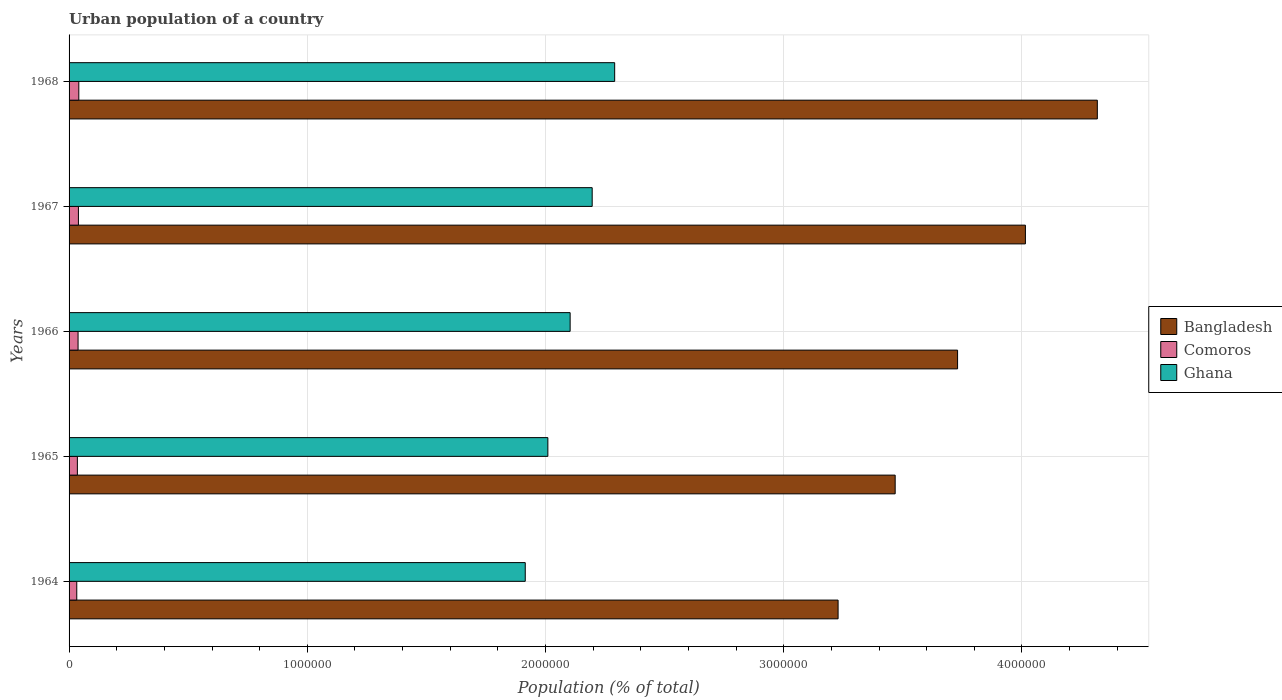How many bars are there on the 3rd tick from the top?
Your response must be concise. 3. What is the label of the 3rd group of bars from the top?
Ensure brevity in your answer.  1966. What is the urban population in Ghana in 1966?
Make the answer very short. 2.10e+06. Across all years, what is the maximum urban population in Ghana?
Provide a short and direct response. 2.29e+06. Across all years, what is the minimum urban population in Ghana?
Provide a succinct answer. 1.91e+06. In which year was the urban population in Comoros maximum?
Offer a very short reply. 1968. In which year was the urban population in Ghana minimum?
Offer a very short reply. 1964. What is the total urban population in Comoros in the graph?
Offer a terse response. 1.85e+05. What is the difference between the urban population in Comoros in 1965 and that in 1967?
Make the answer very short. -4380. What is the difference between the urban population in Ghana in 1966 and the urban population in Bangladesh in 1968?
Keep it short and to the point. -2.21e+06. What is the average urban population in Ghana per year?
Provide a succinct answer. 2.10e+06. In the year 1964, what is the difference between the urban population in Ghana and urban population in Comoros?
Offer a very short reply. 1.88e+06. What is the ratio of the urban population in Comoros in 1965 to that in 1968?
Keep it short and to the point. 0.85. Is the difference between the urban population in Ghana in 1966 and 1968 greater than the difference between the urban population in Comoros in 1966 and 1968?
Give a very brief answer. No. What is the difference between the highest and the second highest urban population in Bangladesh?
Make the answer very short. 3.02e+05. What is the difference between the highest and the lowest urban population in Ghana?
Your response must be concise. 3.75e+05. Is the sum of the urban population in Comoros in 1965 and 1966 greater than the maximum urban population in Bangladesh across all years?
Keep it short and to the point. No. What does the 2nd bar from the top in 1967 represents?
Your response must be concise. Comoros. What does the 2nd bar from the bottom in 1966 represents?
Offer a terse response. Comoros. How many bars are there?
Provide a short and direct response. 15. Are all the bars in the graph horizontal?
Make the answer very short. Yes. What is the difference between two consecutive major ticks on the X-axis?
Offer a terse response. 1.00e+06. Are the values on the major ticks of X-axis written in scientific E-notation?
Give a very brief answer. No. Does the graph contain grids?
Give a very brief answer. Yes. Where does the legend appear in the graph?
Your answer should be compact. Center right. How are the legend labels stacked?
Your answer should be very brief. Vertical. What is the title of the graph?
Ensure brevity in your answer.  Urban population of a country. Does "OECD members" appear as one of the legend labels in the graph?
Your answer should be very brief. No. What is the label or title of the X-axis?
Offer a very short reply. Population (% of total). What is the Population (% of total) in Bangladesh in 1964?
Offer a very short reply. 3.23e+06. What is the Population (% of total) of Comoros in 1964?
Make the answer very short. 3.23e+04. What is the Population (% of total) of Ghana in 1964?
Provide a succinct answer. 1.91e+06. What is the Population (% of total) in Bangladesh in 1965?
Provide a short and direct response. 3.47e+06. What is the Population (% of total) in Comoros in 1965?
Keep it short and to the point. 3.49e+04. What is the Population (% of total) in Ghana in 1965?
Your answer should be compact. 2.01e+06. What is the Population (% of total) in Bangladesh in 1966?
Your answer should be compact. 3.73e+06. What is the Population (% of total) of Comoros in 1966?
Keep it short and to the point. 3.77e+04. What is the Population (% of total) of Ghana in 1966?
Provide a short and direct response. 2.10e+06. What is the Population (% of total) of Bangladesh in 1967?
Your answer should be very brief. 4.01e+06. What is the Population (% of total) in Comoros in 1967?
Provide a succinct answer. 3.93e+04. What is the Population (% of total) in Ghana in 1967?
Your response must be concise. 2.20e+06. What is the Population (% of total) of Bangladesh in 1968?
Your answer should be very brief. 4.32e+06. What is the Population (% of total) in Comoros in 1968?
Keep it short and to the point. 4.09e+04. What is the Population (% of total) of Ghana in 1968?
Provide a succinct answer. 2.29e+06. Across all years, what is the maximum Population (% of total) of Bangladesh?
Offer a terse response. 4.32e+06. Across all years, what is the maximum Population (% of total) of Comoros?
Make the answer very short. 4.09e+04. Across all years, what is the maximum Population (% of total) of Ghana?
Your answer should be very brief. 2.29e+06. Across all years, what is the minimum Population (% of total) of Bangladesh?
Give a very brief answer. 3.23e+06. Across all years, what is the minimum Population (% of total) in Comoros?
Offer a very short reply. 3.23e+04. Across all years, what is the minimum Population (% of total) in Ghana?
Provide a succinct answer. 1.91e+06. What is the total Population (% of total) of Bangladesh in the graph?
Offer a very short reply. 1.88e+07. What is the total Population (% of total) in Comoros in the graph?
Offer a terse response. 1.85e+05. What is the total Population (% of total) of Ghana in the graph?
Your response must be concise. 1.05e+07. What is the difference between the Population (% of total) of Bangladesh in 1964 and that in 1965?
Your answer should be very brief. -2.40e+05. What is the difference between the Population (% of total) in Comoros in 1964 and that in 1965?
Your answer should be very brief. -2601. What is the difference between the Population (% of total) in Ghana in 1964 and that in 1965?
Offer a very short reply. -9.49e+04. What is the difference between the Population (% of total) of Bangladesh in 1964 and that in 1966?
Provide a succinct answer. -5.02e+05. What is the difference between the Population (% of total) in Comoros in 1964 and that in 1966?
Offer a terse response. -5442. What is the difference between the Population (% of total) in Ghana in 1964 and that in 1966?
Ensure brevity in your answer.  -1.88e+05. What is the difference between the Population (% of total) of Bangladesh in 1964 and that in 1967?
Provide a short and direct response. -7.86e+05. What is the difference between the Population (% of total) of Comoros in 1964 and that in 1967?
Your response must be concise. -6981. What is the difference between the Population (% of total) in Ghana in 1964 and that in 1967?
Your answer should be compact. -2.81e+05. What is the difference between the Population (% of total) in Bangladesh in 1964 and that in 1968?
Your response must be concise. -1.09e+06. What is the difference between the Population (% of total) in Comoros in 1964 and that in 1968?
Your response must be concise. -8608. What is the difference between the Population (% of total) of Ghana in 1964 and that in 1968?
Offer a terse response. -3.75e+05. What is the difference between the Population (% of total) in Bangladesh in 1965 and that in 1966?
Offer a terse response. -2.62e+05. What is the difference between the Population (% of total) in Comoros in 1965 and that in 1966?
Your response must be concise. -2841. What is the difference between the Population (% of total) of Ghana in 1965 and that in 1966?
Offer a terse response. -9.35e+04. What is the difference between the Population (% of total) of Bangladesh in 1965 and that in 1967?
Your response must be concise. -5.47e+05. What is the difference between the Population (% of total) in Comoros in 1965 and that in 1967?
Your answer should be very brief. -4380. What is the difference between the Population (% of total) in Ghana in 1965 and that in 1967?
Ensure brevity in your answer.  -1.86e+05. What is the difference between the Population (% of total) in Bangladesh in 1965 and that in 1968?
Your answer should be very brief. -8.49e+05. What is the difference between the Population (% of total) of Comoros in 1965 and that in 1968?
Your answer should be compact. -6007. What is the difference between the Population (% of total) in Ghana in 1965 and that in 1968?
Your answer should be very brief. -2.80e+05. What is the difference between the Population (% of total) in Bangladesh in 1966 and that in 1967?
Provide a succinct answer. -2.85e+05. What is the difference between the Population (% of total) in Comoros in 1966 and that in 1967?
Give a very brief answer. -1539. What is the difference between the Population (% of total) of Ghana in 1966 and that in 1967?
Give a very brief answer. -9.26e+04. What is the difference between the Population (% of total) of Bangladesh in 1966 and that in 1968?
Make the answer very short. -5.87e+05. What is the difference between the Population (% of total) of Comoros in 1966 and that in 1968?
Provide a short and direct response. -3166. What is the difference between the Population (% of total) of Ghana in 1966 and that in 1968?
Make the answer very short. -1.87e+05. What is the difference between the Population (% of total) of Bangladesh in 1967 and that in 1968?
Keep it short and to the point. -3.02e+05. What is the difference between the Population (% of total) in Comoros in 1967 and that in 1968?
Your answer should be compact. -1627. What is the difference between the Population (% of total) of Ghana in 1967 and that in 1968?
Keep it short and to the point. -9.44e+04. What is the difference between the Population (% of total) of Bangladesh in 1964 and the Population (% of total) of Comoros in 1965?
Offer a terse response. 3.19e+06. What is the difference between the Population (% of total) of Bangladesh in 1964 and the Population (% of total) of Ghana in 1965?
Ensure brevity in your answer.  1.22e+06. What is the difference between the Population (% of total) in Comoros in 1964 and the Population (% of total) in Ghana in 1965?
Your response must be concise. -1.98e+06. What is the difference between the Population (% of total) in Bangladesh in 1964 and the Population (% of total) in Comoros in 1966?
Provide a short and direct response. 3.19e+06. What is the difference between the Population (% of total) of Bangladesh in 1964 and the Population (% of total) of Ghana in 1966?
Your answer should be very brief. 1.12e+06. What is the difference between the Population (% of total) in Comoros in 1964 and the Population (% of total) in Ghana in 1966?
Ensure brevity in your answer.  -2.07e+06. What is the difference between the Population (% of total) in Bangladesh in 1964 and the Population (% of total) in Comoros in 1967?
Offer a terse response. 3.19e+06. What is the difference between the Population (% of total) in Bangladesh in 1964 and the Population (% of total) in Ghana in 1967?
Ensure brevity in your answer.  1.03e+06. What is the difference between the Population (% of total) in Comoros in 1964 and the Population (% of total) in Ghana in 1967?
Your answer should be very brief. -2.16e+06. What is the difference between the Population (% of total) in Bangladesh in 1964 and the Population (% of total) in Comoros in 1968?
Provide a short and direct response. 3.19e+06. What is the difference between the Population (% of total) in Bangladesh in 1964 and the Population (% of total) in Ghana in 1968?
Provide a succinct answer. 9.38e+05. What is the difference between the Population (% of total) in Comoros in 1964 and the Population (% of total) in Ghana in 1968?
Your answer should be very brief. -2.26e+06. What is the difference between the Population (% of total) of Bangladesh in 1965 and the Population (% of total) of Comoros in 1966?
Provide a short and direct response. 3.43e+06. What is the difference between the Population (% of total) of Bangladesh in 1965 and the Population (% of total) of Ghana in 1966?
Provide a short and direct response. 1.36e+06. What is the difference between the Population (% of total) in Comoros in 1965 and the Population (% of total) in Ghana in 1966?
Your answer should be very brief. -2.07e+06. What is the difference between the Population (% of total) in Bangladesh in 1965 and the Population (% of total) in Comoros in 1967?
Make the answer very short. 3.43e+06. What is the difference between the Population (% of total) of Bangladesh in 1965 and the Population (% of total) of Ghana in 1967?
Give a very brief answer. 1.27e+06. What is the difference between the Population (% of total) of Comoros in 1965 and the Population (% of total) of Ghana in 1967?
Your answer should be compact. -2.16e+06. What is the difference between the Population (% of total) of Bangladesh in 1965 and the Population (% of total) of Comoros in 1968?
Ensure brevity in your answer.  3.43e+06. What is the difference between the Population (% of total) in Bangladesh in 1965 and the Population (% of total) in Ghana in 1968?
Your answer should be very brief. 1.18e+06. What is the difference between the Population (% of total) of Comoros in 1965 and the Population (% of total) of Ghana in 1968?
Your response must be concise. -2.26e+06. What is the difference between the Population (% of total) in Bangladesh in 1966 and the Population (% of total) in Comoros in 1967?
Your answer should be very brief. 3.69e+06. What is the difference between the Population (% of total) of Bangladesh in 1966 and the Population (% of total) of Ghana in 1967?
Your answer should be very brief. 1.53e+06. What is the difference between the Population (% of total) of Comoros in 1966 and the Population (% of total) of Ghana in 1967?
Provide a short and direct response. -2.16e+06. What is the difference between the Population (% of total) of Bangladesh in 1966 and the Population (% of total) of Comoros in 1968?
Keep it short and to the point. 3.69e+06. What is the difference between the Population (% of total) in Bangladesh in 1966 and the Population (% of total) in Ghana in 1968?
Provide a short and direct response. 1.44e+06. What is the difference between the Population (% of total) of Comoros in 1966 and the Population (% of total) of Ghana in 1968?
Provide a succinct answer. -2.25e+06. What is the difference between the Population (% of total) in Bangladesh in 1967 and the Population (% of total) in Comoros in 1968?
Make the answer very short. 3.97e+06. What is the difference between the Population (% of total) in Bangladesh in 1967 and the Population (% of total) in Ghana in 1968?
Offer a terse response. 1.72e+06. What is the difference between the Population (% of total) in Comoros in 1967 and the Population (% of total) in Ghana in 1968?
Provide a short and direct response. -2.25e+06. What is the average Population (% of total) of Bangladesh per year?
Provide a short and direct response. 3.75e+06. What is the average Population (% of total) in Comoros per year?
Keep it short and to the point. 3.70e+04. What is the average Population (% of total) in Ghana per year?
Offer a terse response. 2.10e+06. In the year 1964, what is the difference between the Population (% of total) in Bangladesh and Population (% of total) in Comoros?
Provide a short and direct response. 3.20e+06. In the year 1964, what is the difference between the Population (% of total) of Bangladesh and Population (% of total) of Ghana?
Provide a short and direct response. 1.31e+06. In the year 1964, what is the difference between the Population (% of total) in Comoros and Population (% of total) in Ghana?
Your answer should be compact. -1.88e+06. In the year 1965, what is the difference between the Population (% of total) of Bangladesh and Population (% of total) of Comoros?
Provide a succinct answer. 3.43e+06. In the year 1965, what is the difference between the Population (% of total) of Bangladesh and Population (% of total) of Ghana?
Your answer should be compact. 1.46e+06. In the year 1965, what is the difference between the Population (% of total) of Comoros and Population (% of total) of Ghana?
Ensure brevity in your answer.  -1.98e+06. In the year 1966, what is the difference between the Population (% of total) of Bangladesh and Population (% of total) of Comoros?
Provide a short and direct response. 3.69e+06. In the year 1966, what is the difference between the Population (% of total) in Bangladesh and Population (% of total) in Ghana?
Your answer should be very brief. 1.63e+06. In the year 1966, what is the difference between the Population (% of total) of Comoros and Population (% of total) of Ghana?
Provide a short and direct response. -2.07e+06. In the year 1967, what is the difference between the Population (% of total) of Bangladesh and Population (% of total) of Comoros?
Your answer should be compact. 3.98e+06. In the year 1967, what is the difference between the Population (% of total) of Bangladesh and Population (% of total) of Ghana?
Your response must be concise. 1.82e+06. In the year 1967, what is the difference between the Population (% of total) of Comoros and Population (% of total) of Ghana?
Keep it short and to the point. -2.16e+06. In the year 1968, what is the difference between the Population (% of total) in Bangladesh and Population (% of total) in Comoros?
Keep it short and to the point. 4.28e+06. In the year 1968, what is the difference between the Population (% of total) of Bangladesh and Population (% of total) of Ghana?
Ensure brevity in your answer.  2.03e+06. In the year 1968, what is the difference between the Population (% of total) of Comoros and Population (% of total) of Ghana?
Your response must be concise. -2.25e+06. What is the ratio of the Population (% of total) in Bangladesh in 1964 to that in 1965?
Give a very brief answer. 0.93. What is the ratio of the Population (% of total) of Comoros in 1964 to that in 1965?
Ensure brevity in your answer.  0.93. What is the ratio of the Population (% of total) in Ghana in 1964 to that in 1965?
Keep it short and to the point. 0.95. What is the ratio of the Population (% of total) of Bangladesh in 1964 to that in 1966?
Your response must be concise. 0.87. What is the ratio of the Population (% of total) in Comoros in 1964 to that in 1966?
Keep it short and to the point. 0.86. What is the ratio of the Population (% of total) of Ghana in 1964 to that in 1966?
Your answer should be compact. 0.91. What is the ratio of the Population (% of total) in Bangladesh in 1964 to that in 1967?
Offer a very short reply. 0.8. What is the ratio of the Population (% of total) in Comoros in 1964 to that in 1967?
Your answer should be compact. 0.82. What is the ratio of the Population (% of total) of Ghana in 1964 to that in 1967?
Ensure brevity in your answer.  0.87. What is the ratio of the Population (% of total) in Bangladesh in 1964 to that in 1968?
Ensure brevity in your answer.  0.75. What is the ratio of the Population (% of total) in Comoros in 1964 to that in 1968?
Your answer should be very brief. 0.79. What is the ratio of the Population (% of total) of Ghana in 1964 to that in 1968?
Keep it short and to the point. 0.84. What is the ratio of the Population (% of total) of Bangladesh in 1965 to that in 1966?
Your response must be concise. 0.93. What is the ratio of the Population (% of total) of Comoros in 1965 to that in 1966?
Keep it short and to the point. 0.92. What is the ratio of the Population (% of total) of Ghana in 1965 to that in 1966?
Your response must be concise. 0.96. What is the ratio of the Population (% of total) in Bangladesh in 1965 to that in 1967?
Your response must be concise. 0.86. What is the ratio of the Population (% of total) of Comoros in 1965 to that in 1967?
Make the answer very short. 0.89. What is the ratio of the Population (% of total) in Ghana in 1965 to that in 1967?
Give a very brief answer. 0.92. What is the ratio of the Population (% of total) of Bangladesh in 1965 to that in 1968?
Give a very brief answer. 0.8. What is the ratio of the Population (% of total) in Comoros in 1965 to that in 1968?
Provide a succinct answer. 0.85. What is the ratio of the Population (% of total) in Ghana in 1965 to that in 1968?
Keep it short and to the point. 0.88. What is the ratio of the Population (% of total) of Bangladesh in 1966 to that in 1967?
Keep it short and to the point. 0.93. What is the ratio of the Population (% of total) in Comoros in 1966 to that in 1967?
Keep it short and to the point. 0.96. What is the ratio of the Population (% of total) in Ghana in 1966 to that in 1967?
Provide a succinct answer. 0.96. What is the ratio of the Population (% of total) of Bangladesh in 1966 to that in 1968?
Offer a very short reply. 0.86. What is the ratio of the Population (% of total) of Comoros in 1966 to that in 1968?
Give a very brief answer. 0.92. What is the ratio of the Population (% of total) of Ghana in 1966 to that in 1968?
Keep it short and to the point. 0.92. What is the ratio of the Population (% of total) in Bangladesh in 1967 to that in 1968?
Give a very brief answer. 0.93. What is the ratio of the Population (% of total) in Comoros in 1967 to that in 1968?
Offer a very short reply. 0.96. What is the ratio of the Population (% of total) in Ghana in 1967 to that in 1968?
Provide a succinct answer. 0.96. What is the difference between the highest and the second highest Population (% of total) of Bangladesh?
Provide a succinct answer. 3.02e+05. What is the difference between the highest and the second highest Population (% of total) in Comoros?
Your answer should be very brief. 1627. What is the difference between the highest and the second highest Population (% of total) in Ghana?
Keep it short and to the point. 9.44e+04. What is the difference between the highest and the lowest Population (% of total) in Bangladesh?
Offer a very short reply. 1.09e+06. What is the difference between the highest and the lowest Population (% of total) in Comoros?
Your response must be concise. 8608. What is the difference between the highest and the lowest Population (% of total) in Ghana?
Provide a succinct answer. 3.75e+05. 